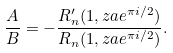<formula> <loc_0><loc_0><loc_500><loc_500>\frac { A } { B } = - \frac { R _ { n } ^ { \prime } ( 1 , z a e ^ { \pi i / 2 } ) } { R _ { n } ( 1 , z a e ^ { \pi i / 2 } ) } .</formula> 